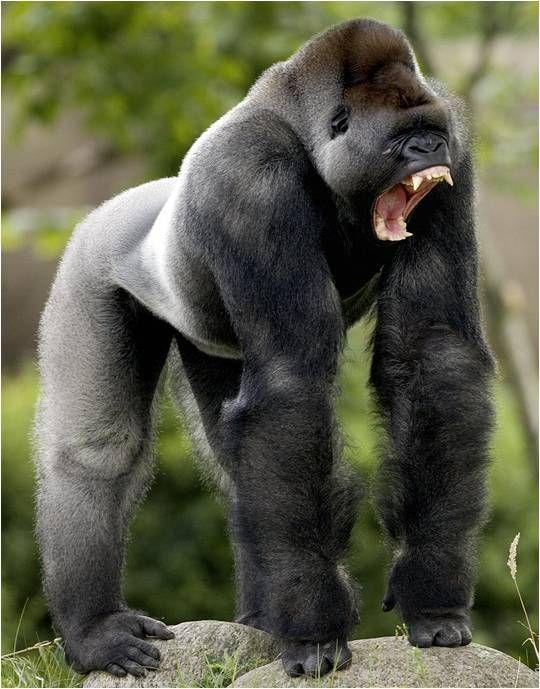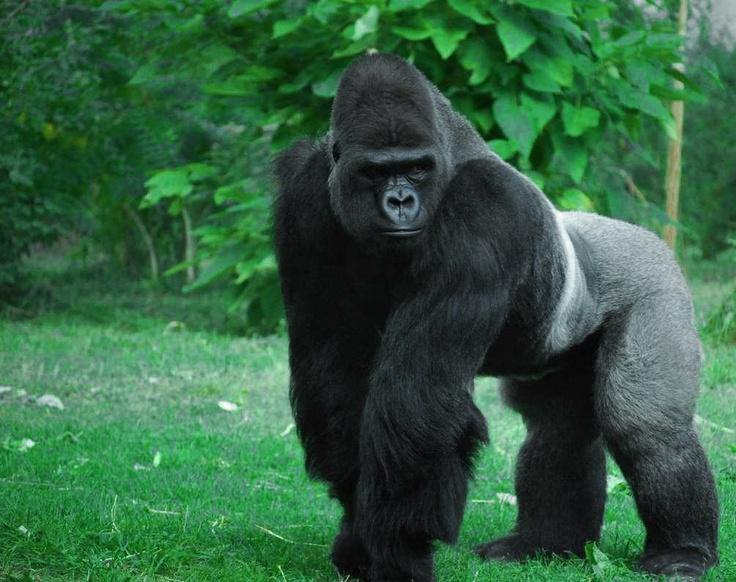The first image is the image on the left, the second image is the image on the right. For the images displayed, is the sentence "The gorilla in the image on the right is standing completely upright." factually correct? Answer yes or no. No. The first image is the image on the left, the second image is the image on the right. Evaluate the accuracy of this statement regarding the images: "There is at least one monkey standing on all four paws.". Is it true? Answer yes or no. Yes. 